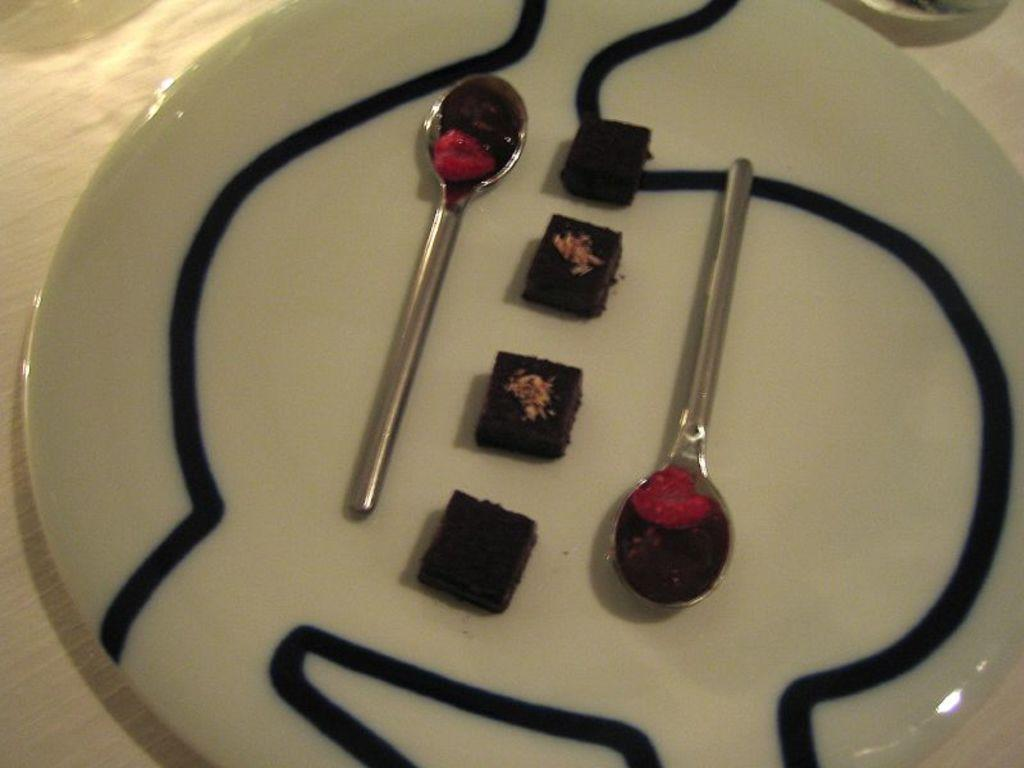What is located in the foreground of the image? There is a plate in the foreground of the image. What is on the plate? The plate has two spoons and four pieces of cake on it. Where is the plate placed? The plate is placed on a table. In what type of setting is the image taken? The image is taken in a room. What instrument is the judge playing in the image? There is no judge or instrument present in the image. 